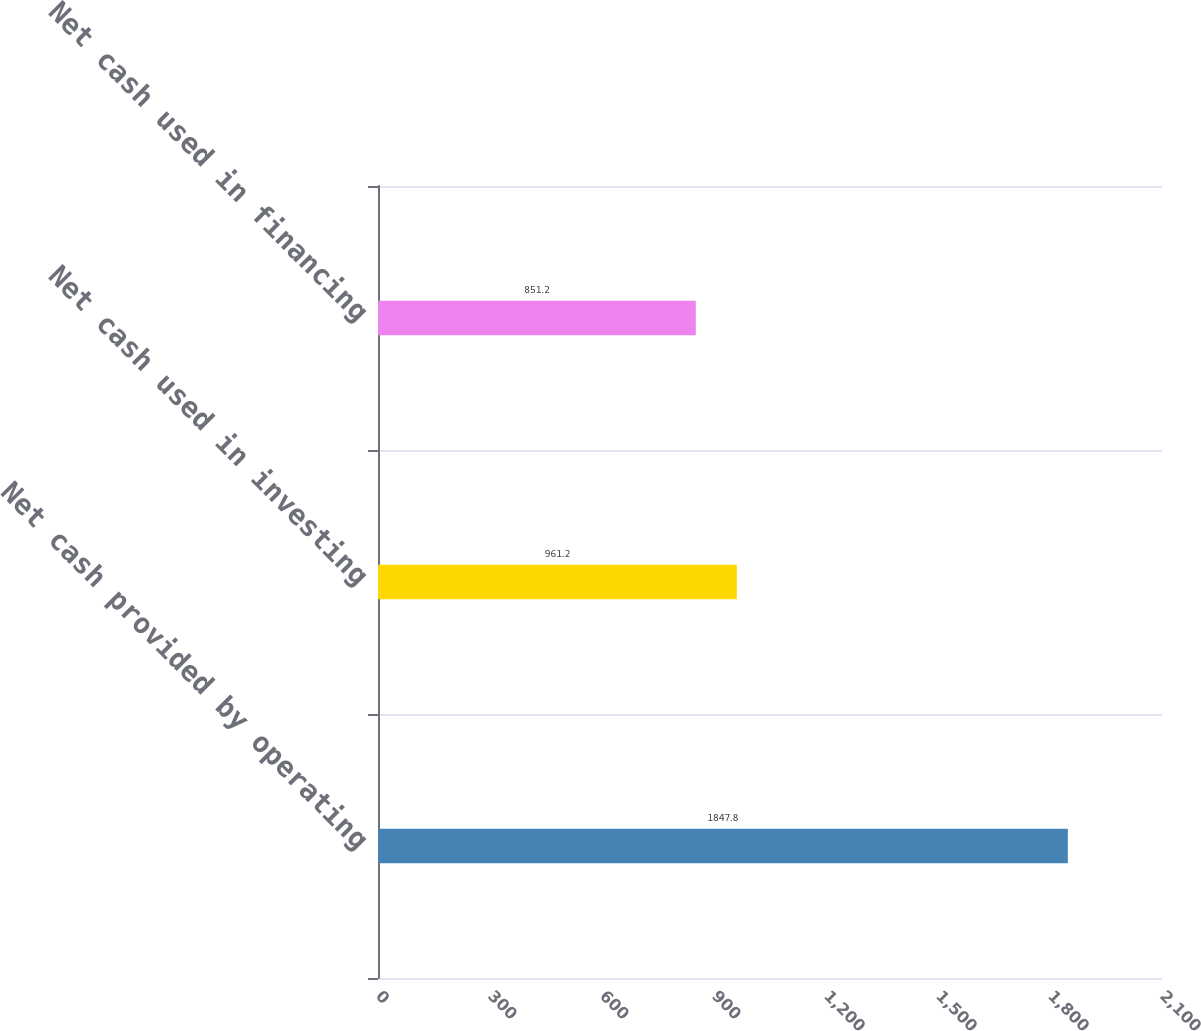Convert chart. <chart><loc_0><loc_0><loc_500><loc_500><bar_chart><fcel>Net cash provided by operating<fcel>Net cash used in investing<fcel>Net cash used in financing<nl><fcel>1847.8<fcel>961.2<fcel>851.2<nl></chart> 